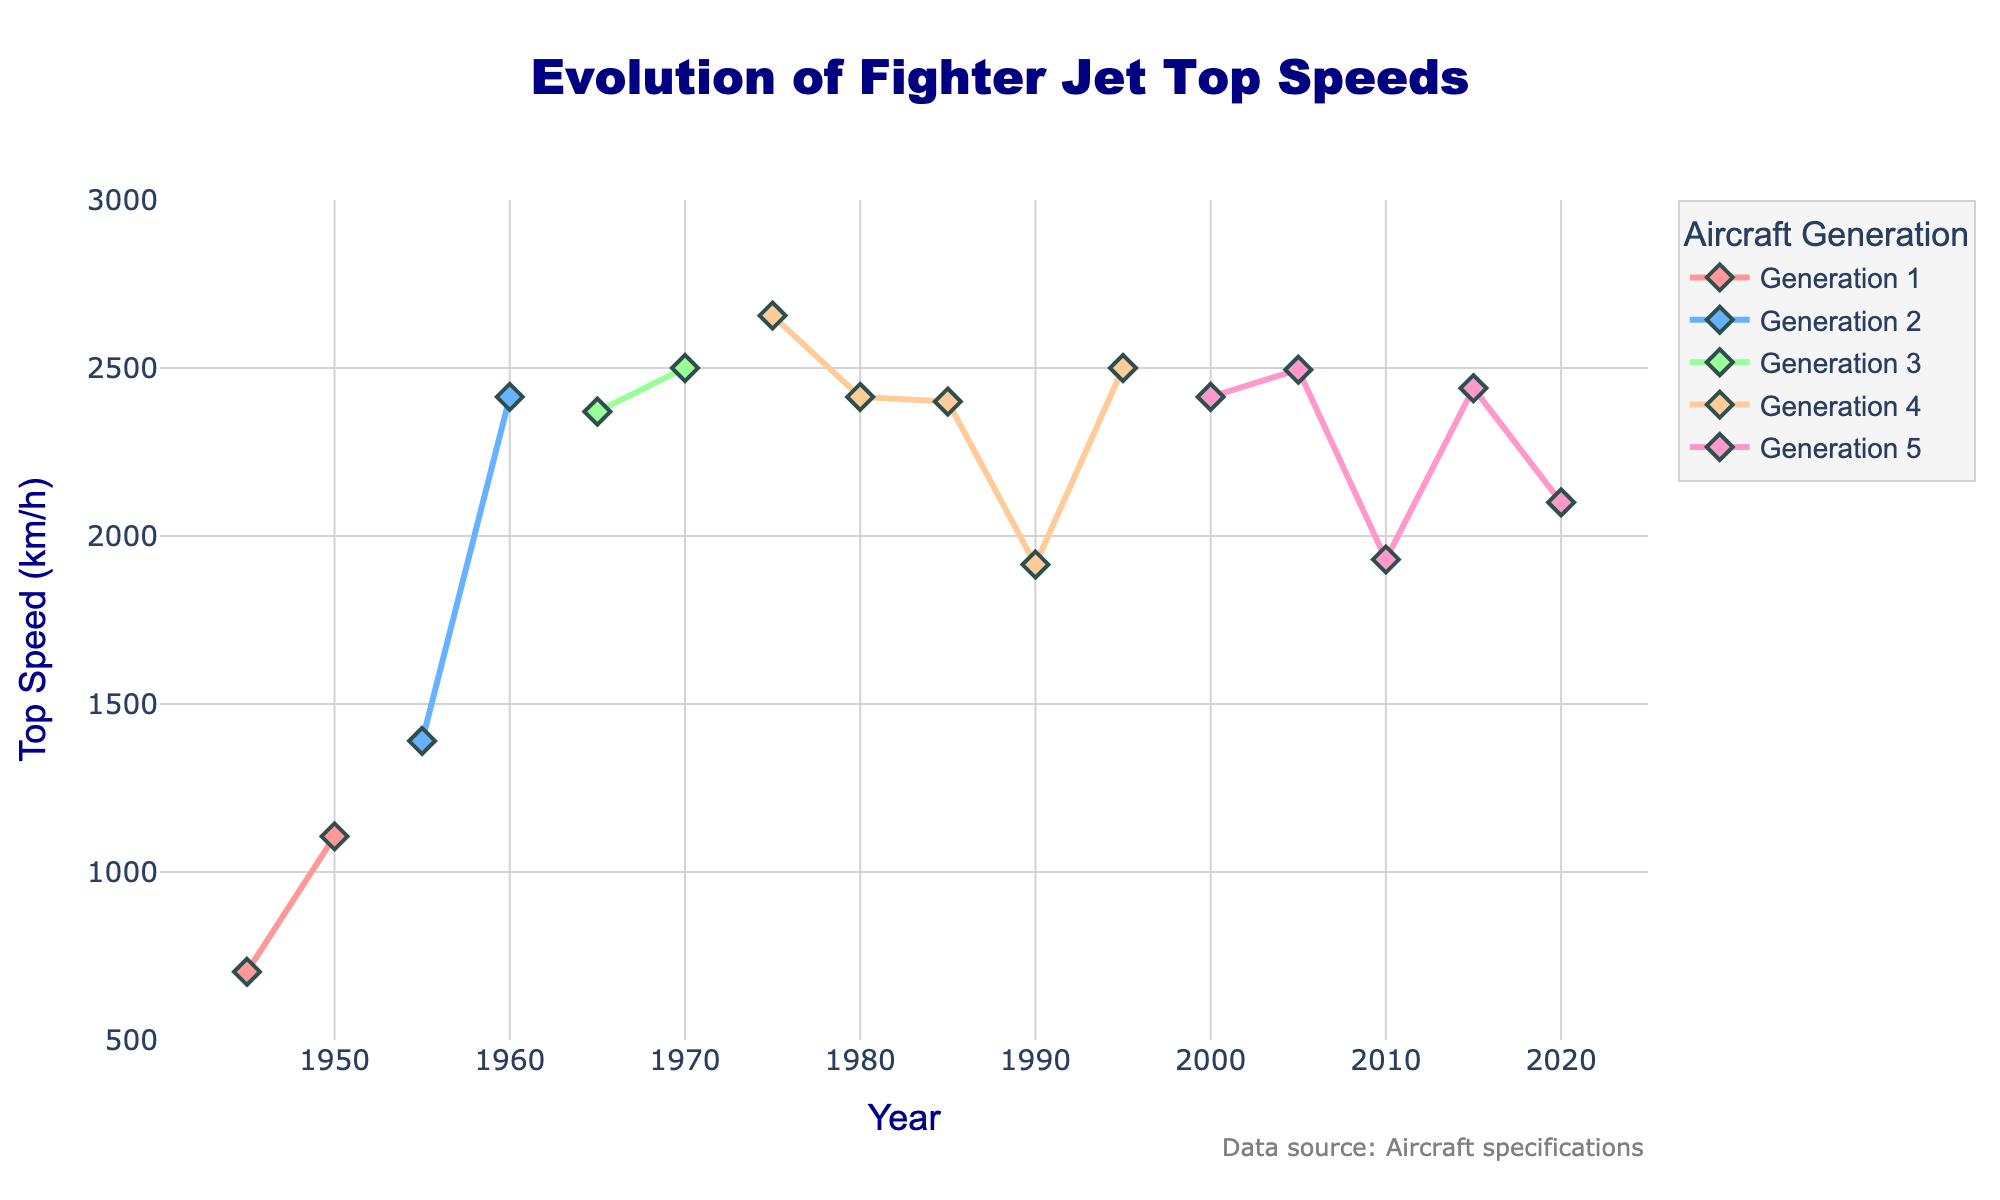What's the average top speed of fighter jets from Generation 3? To find the average top speed, calculate the sum of the top speeds for all Generation 3 jets and divide by the number of jets. The Generation 3 jets are F-4 Phantom II (2370 km/h) and MiG-23 (2500 km/h). Sum these speeds (2370 + 2500 = 4870) and divide by 2.
Answer: 2435 km/h Which generation shows the most significant increase in top speed compared to its predecessor? To determine this, compare the top speeds of jets at the beginning of each generation to the top speeds of jets at the end of the previous generation. Generation 1 starts at 703 km/h and ends at 1106 km/h. Generation 2 starts at 1390 km/h and ends at 2414 km/h. Generation 3 starts at 2370 km/h and ends at 2500 km/h. Generation 4 starts at 1915 km/h and ends at 2656 km/h. Generation 5 starts at 1930 km/h and ends at 2100 km/h. The most significant increase is from Generation 1 to Generation 2 (2414 - 1106 = 1308 km/h).
Answer: Generation 2 Which aircraft has the highest top speed, and what is it? Look for the highest top speed value on the y-axis across all data points. The MiG-23 and Su-27 both have the highest top speed of 2500 km/h.
Answer: MiG-23 and Su-27, 2500 km/h Is there any aircraft in Generation 4 that has a top speed lower than 2000 km/h? Check the top speed values for Generation 4 jets. The F/A-18 Hornet has a top speed of 1915 km/h, which is below 2000 km/h.
Answer: Yes, F/A-18 Hornet Are there any instances where a later generation jet has a lower top speed than an earlier generation jet? Compare the top speeds of jets in each generation to those in subsequent generations. The F-35 Lightning II from Generation 5 has a top speed of 1930 km/h, which is lower than several Generation 4 jets such as the MiG-29 (2400 km/h) and Su-27 (2500 km/h).
Answer: Yes, F-35 Lightning II What is the top speed difference between the first and the last jet in Generation 4? Identify the first and last jets in Generation 4 and find their top speeds. The first is the F-15 Eagle (2656 km/h), and the last is the Su-27 (2500 km/h). Subtract the second speed from the first: 2656 - 2500 = 156 km/h.
Answer: 156 km/h Identify the year with the highest aircraft top speed. Look at the x-axis to find the year corresponding to the highest value on the y-axis. Both the MiG-23 (1970) and Su-27 (1995) have the highest top speed of 2500 km/h.
Answer: 1970 and 1995 Which generation has the most aircraft in the data set? Count the number of aircraft in each generation. The generations have the following counts: Generation 1 - 2 aircraft, Generation 2 - 2 aircraft, Generation 3 - 2 aircraft, Generation 4 - 5 aircraft, Generation 5 - 6 aircraft.
Answer: Generation 5 Which aircraft in Generation 5 has the highest top speed, and what is it? Compare the top speeds of all Generation 5 jets. The Su-57 has the highest top speed of 2440 km/h.
Answer: Su-57, 2440 km/h 